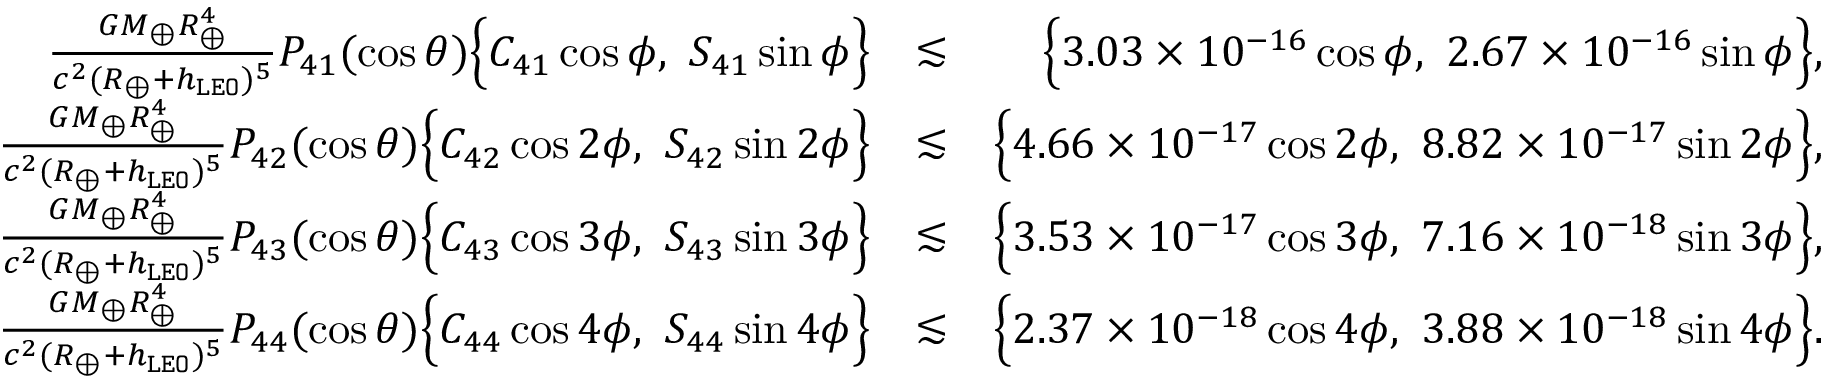<formula> <loc_0><loc_0><loc_500><loc_500>\begin{array} { r l r } { \frac { G M _ { \oplus } R _ { \oplus } ^ { 4 } } { c ^ { 2 } ( R _ { \oplus } + h _ { \tt L E O } ) ^ { 5 } } P _ { 4 1 } ( \cos \theta ) \left \{ C _ { 4 1 } \cos \phi , S _ { 4 1 } \sin \phi \right \} } & { \lesssim } & { \left \{ 3 . 0 3 \times 1 0 ^ { - 1 6 } \cos \phi , 2 . 6 7 \times 1 0 ^ { - 1 6 } \sin \phi \right \} , } \\ { \frac { G M _ { \oplus } R _ { \oplus } ^ { 4 } } { c ^ { 2 } ( R _ { \oplus } + h _ { \tt L E O } ) ^ { 5 } } P _ { 4 2 } ( \cos \theta ) \left \{ C _ { 4 2 } \cos 2 \phi , S _ { 4 2 } \sin 2 \phi \right \} } & { \lesssim } & { \left \{ 4 . 6 6 \times 1 0 ^ { - 1 7 } \cos 2 \phi , 8 . 8 2 \times 1 0 ^ { - 1 7 } \sin 2 \phi \right \} , } \\ { \frac { G M _ { \oplus } R _ { \oplus } ^ { 4 } } { c ^ { 2 } ( R _ { \oplus } + h _ { \tt L E O } ) ^ { 5 } } P _ { 4 3 } ( \cos \theta ) \left \{ C _ { 4 3 } \cos 3 \phi , S _ { 4 3 } \sin 3 \phi \right \} } & { \lesssim } & { \left \{ 3 . 5 3 \times 1 0 ^ { - 1 7 } \cos 3 \phi , 7 . 1 6 \times 1 0 ^ { - 1 8 } \sin 3 \phi \right \} , } \\ { \frac { G M _ { \oplus } R _ { \oplus } ^ { 4 } } { c ^ { 2 } ( R _ { \oplus } + h _ { \tt L E O } ) ^ { 5 } } P _ { 4 4 } ( \cos \theta ) \left \{ C _ { 4 4 } \cos 4 \phi , S _ { 4 4 } \sin 4 \phi \right \} } & { \lesssim } & { \left \{ 2 . 3 7 \times 1 0 ^ { - 1 8 } \cos 4 \phi , 3 . 8 8 \times 1 0 ^ { - 1 8 } \sin 4 \phi \right \} . } \end{array}</formula> 